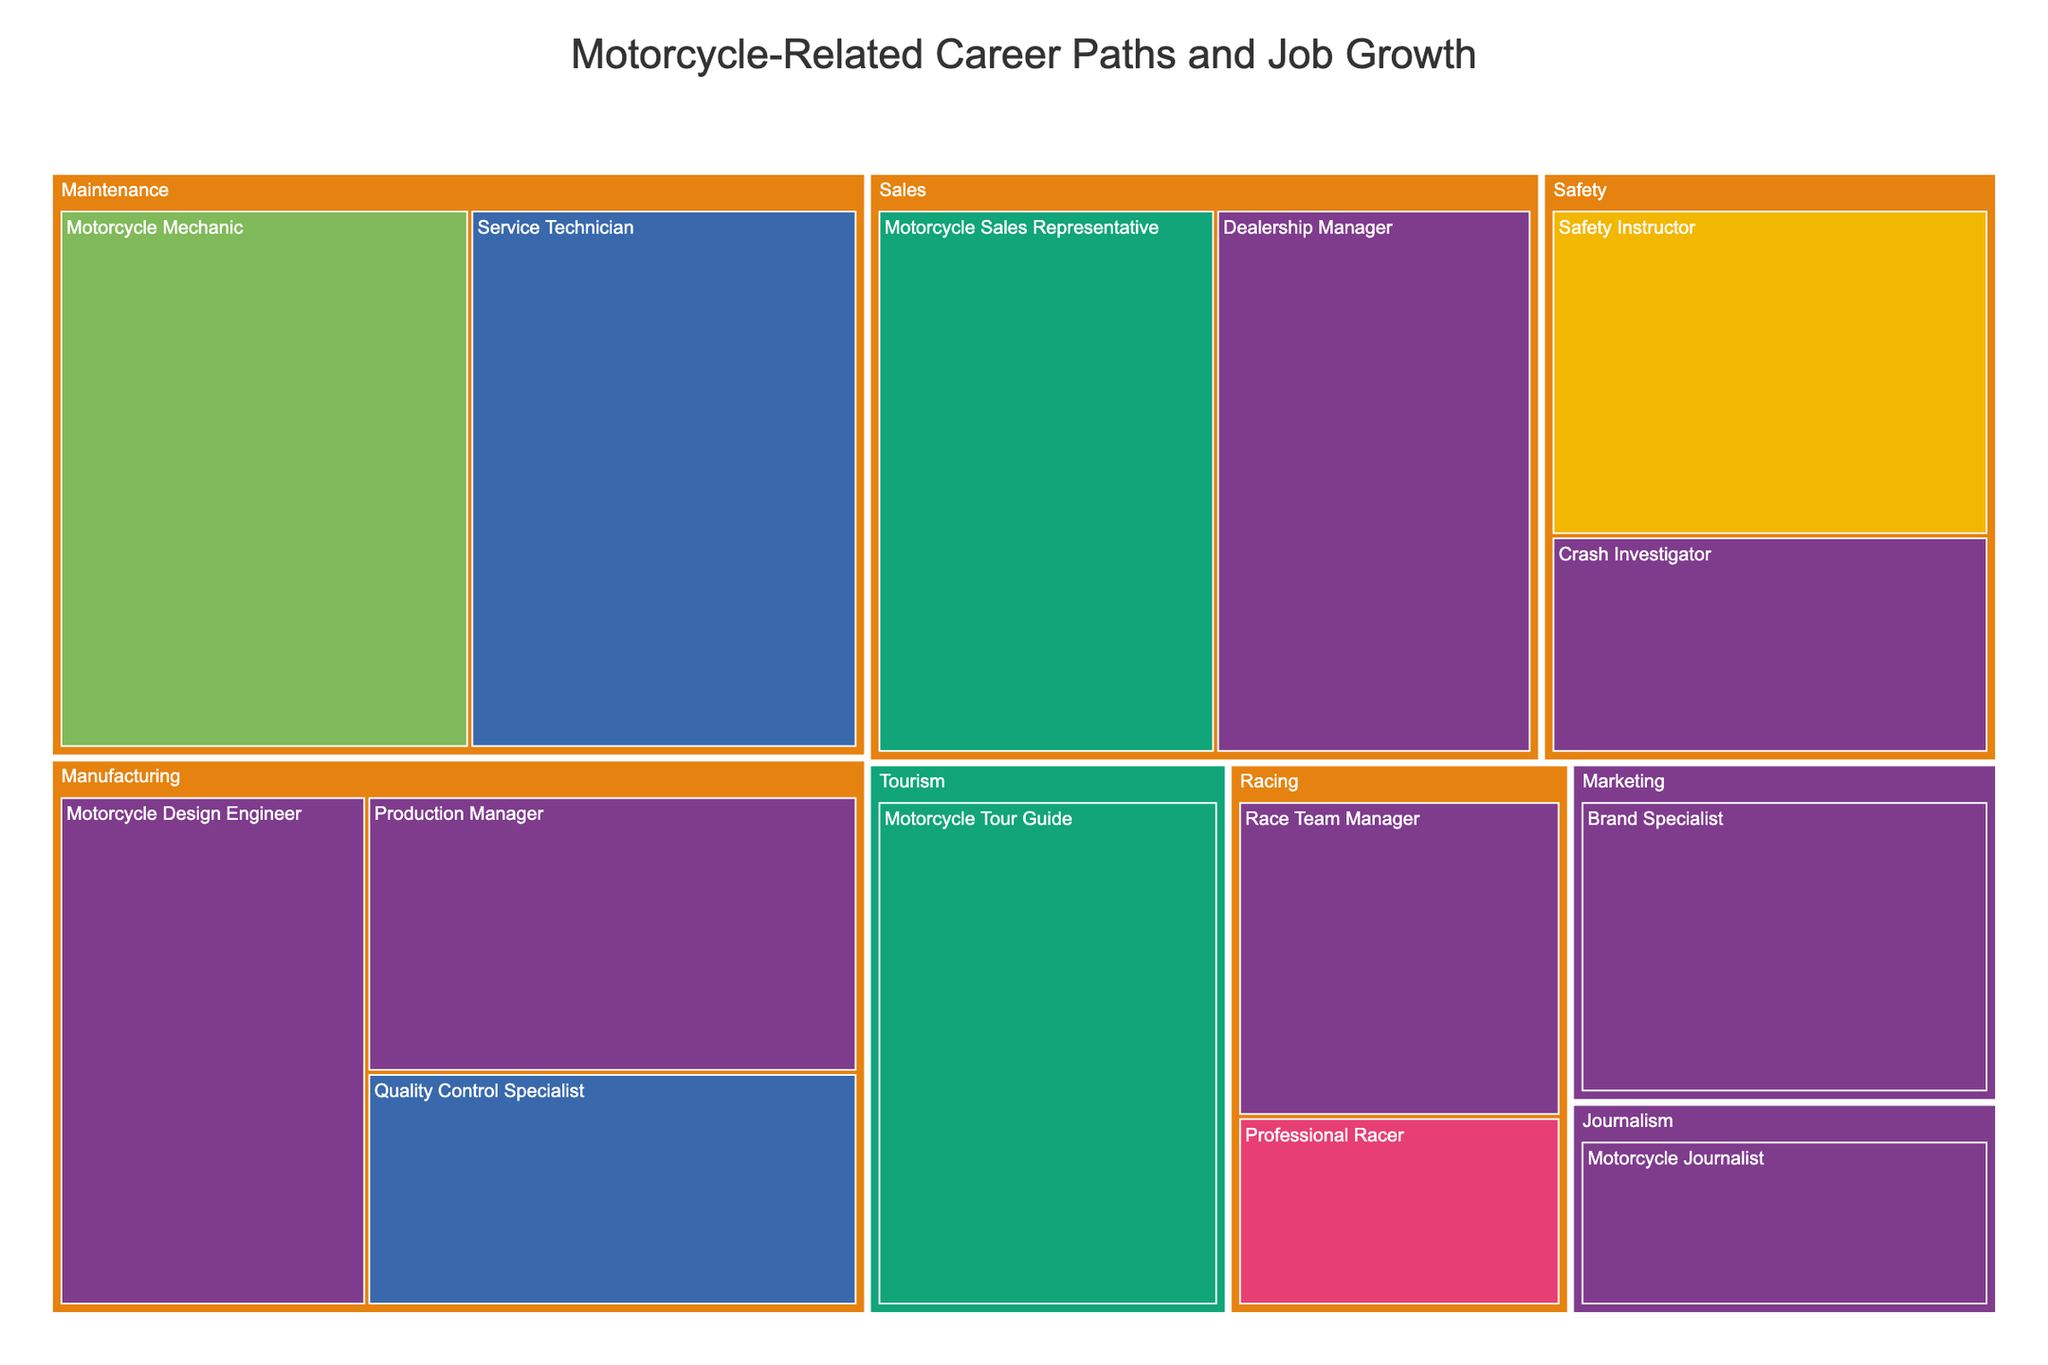What is the job growth for a Motorcycle Mechanic? Refer to the section under the 'Maintenance' industry; the job growth percentage is displayed within the box for the 'Motorcycle Mechanic' career.
Answer: 7.3% Which industry has the highest overall job growth in any of its careers? Look at the individual growth percentages in each industry section and identify the highest value. 'Maintenance' has the highest job growth at 7.3% for 'Motorcycle Mechanic'.
Answer: Maintenance What education level is required for a Motorcycle Design Engineer? Find the 'Motorcycle Design Engineer' career within the 'Manufacturing' industry and see the color indicating its education level.
Answer: Bachelor's Degree Among Safety Instructor and Crash Investigator, which has higher job growth? Compare the job growth percentages of 'Safety Instructor' and 'Crash Investigator' within the 'Safety' category.
Answer: Safety Instructor What is the average job growth for careers in the Sales industry? Identify the job growth percentages for all careers in the 'Sales' industry: 6.1% and 5.7%. Calculate the average: (6.1 + 5.7) / 2 = 5.9.
Answer: 5.9 How many careers in the dataset require a Bachelor's Degree? Count the careers with a Bachelor's Degree indicated by their color in the figure. Careers: Motorcycle Design Engineer, Production Manager, Dealership Manager, Race Team Manager, Crash Investigator, Motorcycle Journalist, Brand Specialist. Total: 7.
Answer: 7 Which career requires the least amount of formal education and what is its job growth? Find the career with 'No Formal Education' and check its job growth percentage. 'Professional Racer' within the 'Racing' industry has this characteristic.
Answer: 2.1% Which career has the highest job growth among those requiring an Associate's Degree? Compare job growth percentages among careers requiring an Associate's Degree: Quality Control Specialist (3.8%) and Service Technician (6.9%).
Answer: Service Technician Is the job growth for a Brand Specialist higher or lower than that of a Professional Racer? Compare their job growth percentages: 'Brand Specialist' (4.3%) and 'Professional Racer' (2.1%).
Answer: Higher What is the predominant education level among careers with job growth above 5%? Identify careers with over 5% job growth and their education levels: Motorcycle Sales Representative (High School Diploma), Dealership Manager (Bachelor's Degree), Motorcycle Mechanic (Vocational Training), Service Technician (Associate's Degree), Motorcycle Tour Guide (High School Diploma).
Answer: Varied 